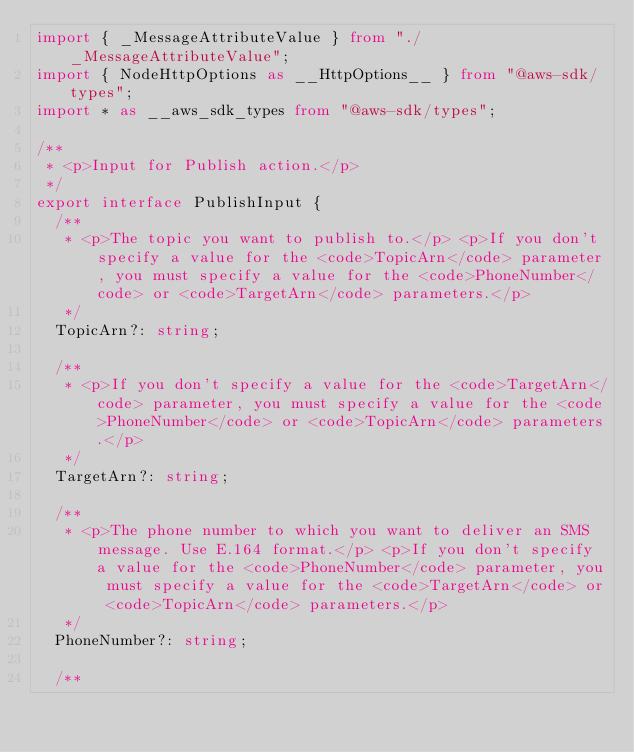Convert code to text. <code><loc_0><loc_0><loc_500><loc_500><_TypeScript_>import { _MessageAttributeValue } from "./_MessageAttributeValue";
import { NodeHttpOptions as __HttpOptions__ } from "@aws-sdk/types";
import * as __aws_sdk_types from "@aws-sdk/types";

/**
 * <p>Input for Publish action.</p>
 */
export interface PublishInput {
  /**
   * <p>The topic you want to publish to.</p> <p>If you don't specify a value for the <code>TopicArn</code> parameter, you must specify a value for the <code>PhoneNumber</code> or <code>TargetArn</code> parameters.</p>
   */
  TopicArn?: string;

  /**
   * <p>If you don't specify a value for the <code>TargetArn</code> parameter, you must specify a value for the <code>PhoneNumber</code> or <code>TopicArn</code> parameters.</p>
   */
  TargetArn?: string;

  /**
   * <p>The phone number to which you want to deliver an SMS message. Use E.164 format.</p> <p>If you don't specify a value for the <code>PhoneNumber</code> parameter, you must specify a value for the <code>TargetArn</code> or <code>TopicArn</code> parameters.</p>
   */
  PhoneNumber?: string;

  /**</code> 